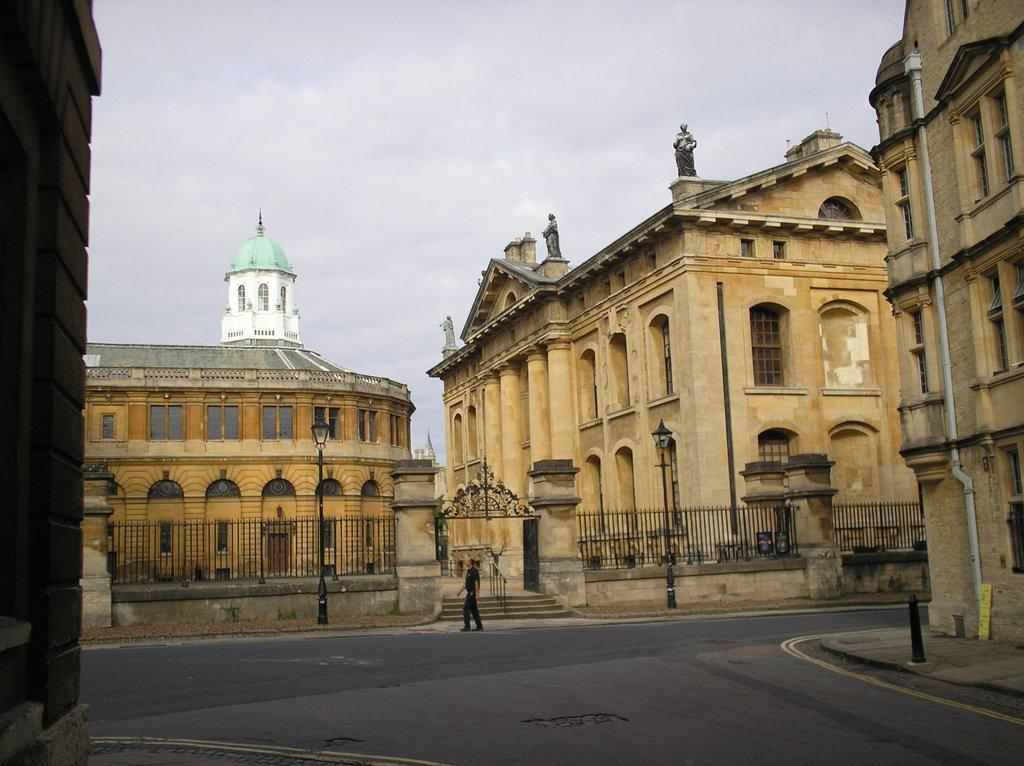What is the person in the image doing? There is a person walking on the road in the image. What can be seen in the background of the image? There are buildings in the background of the image. Is there any additional feature attached to one of the buildings? Yes, there is a statue attached to a building. What type of structures are present along the road? There are light poles in the image. What is visible above the buildings and light poles? The sky is visible in the image. What type of stitch is being used to repair the fireman's uniform in the image? There is no fireman or any reference to a uniform in the image; it features a person walking on the road, buildings, a statue, light poles, and the sky. 